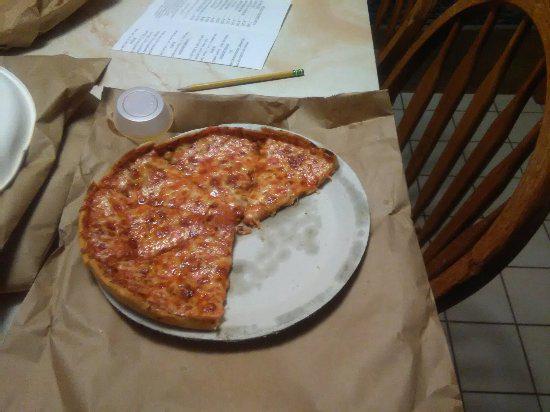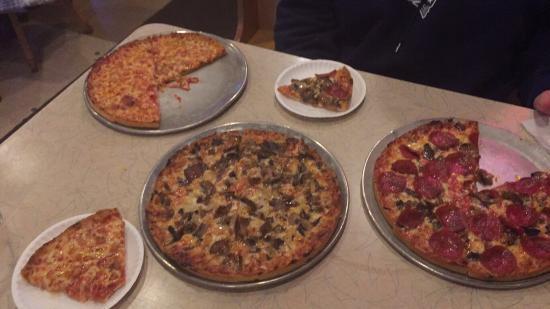The first image is the image on the left, the second image is the image on the right. Assess this claim about the two images: "All of the pizzas are whole without any pieces missing.". Correct or not? Answer yes or no. No. 